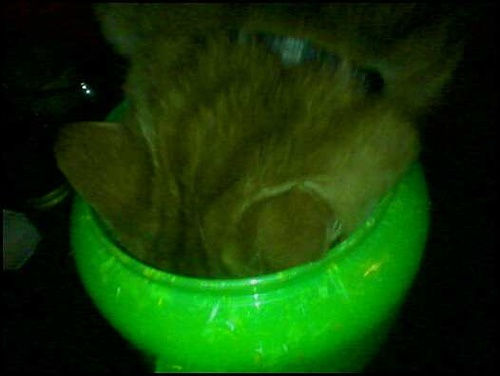Describe the objects in this image and their specific colors. I can see cat in black, darkgreen, and green tones, vase in black, green, lime, and darkgreen tones, and bowl in black, green, lime, and darkgreen tones in this image. 